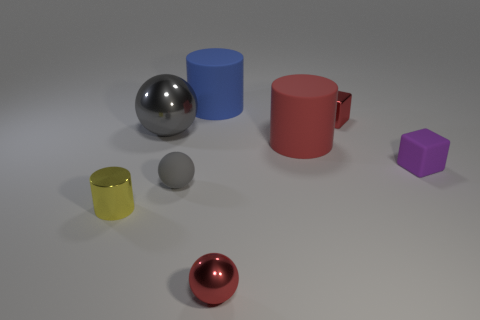Subtract all gray shiny spheres. How many spheres are left? 2 Subtract all cyan blocks. How many gray spheres are left? 2 Subtract all red cubes. How many cubes are left? 1 Subtract 1 cylinders. How many cylinders are left? 2 Add 1 big blue rubber cylinders. How many objects exist? 9 Subtract all cubes. How many objects are left? 6 Subtract 1 gray spheres. How many objects are left? 7 Subtract all red spheres. Subtract all blue cylinders. How many spheres are left? 2 Subtract all tiny cyan metallic cubes. Subtract all tiny yellow objects. How many objects are left? 7 Add 4 tiny gray objects. How many tiny gray objects are left? 5 